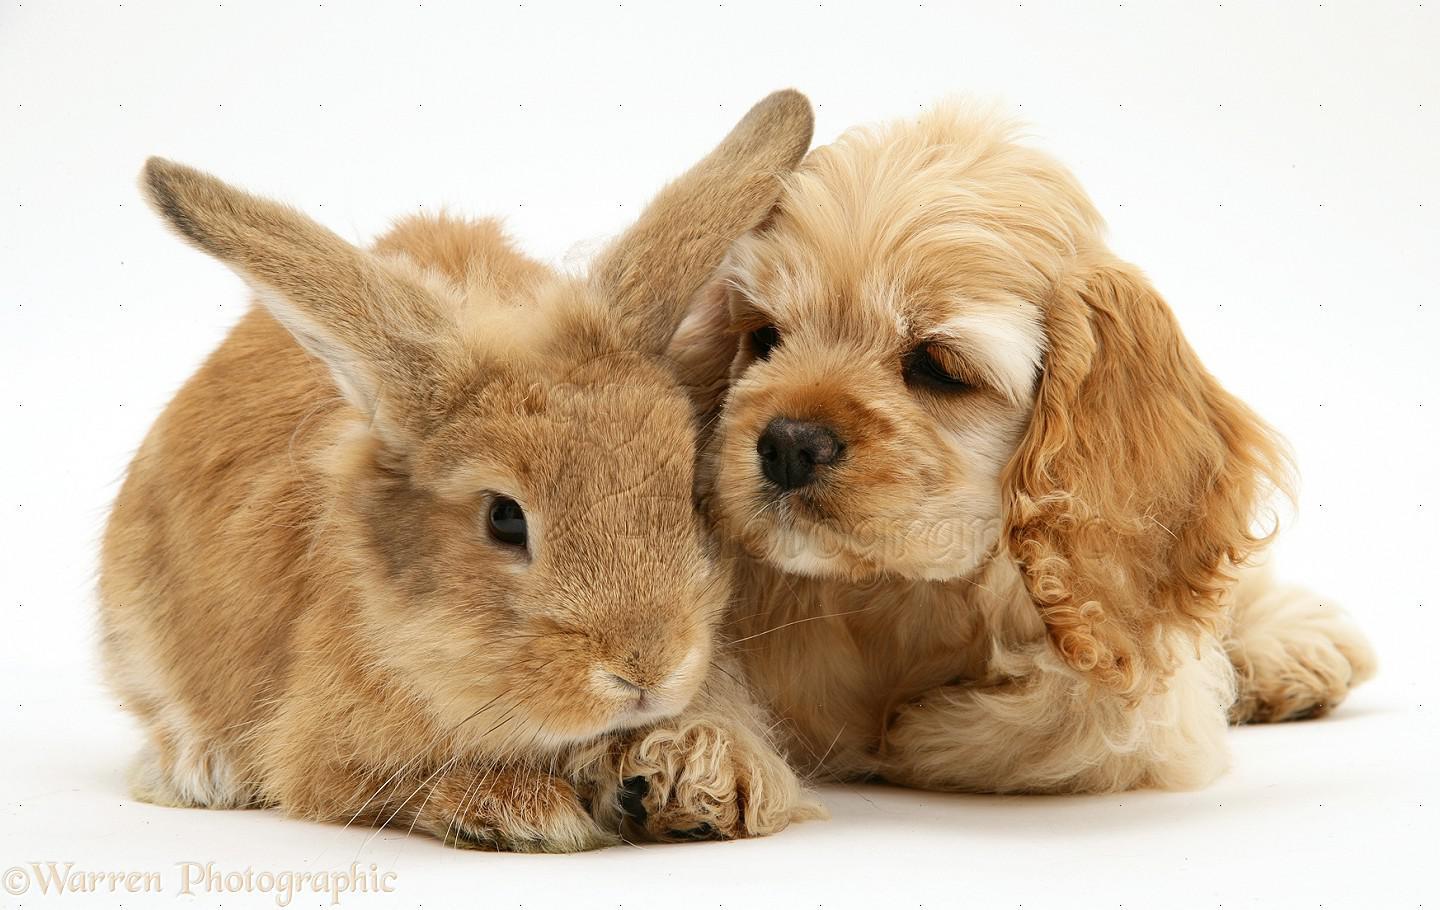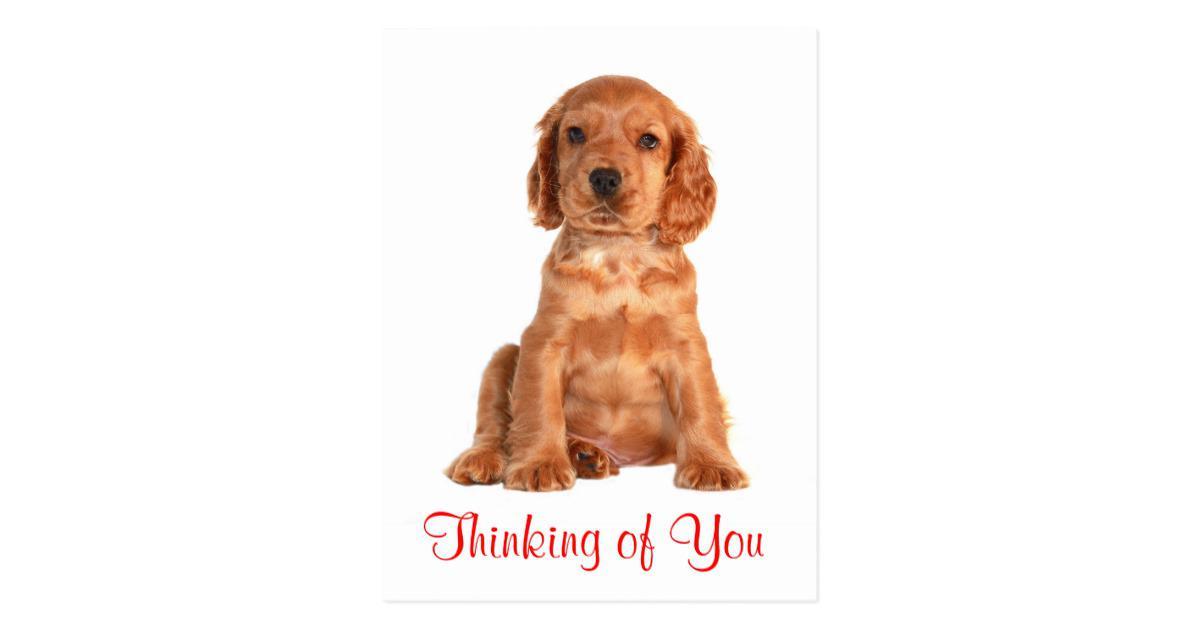The first image is the image on the left, the second image is the image on the right. Considering the images on both sides, is "There is a total of 1 or more dogs whose bodies are facing right." valid? Answer yes or no. No. The first image is the image on the left, the second image is the image on the right. Assess this claim about the two images: "a dog is wearing a coat strapped under it's belly". Correct or not? Answer yes or no. No. 